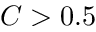<formula> <loc_0><loc_0><loc_500><loc_500>C > 0 . 5</formula> 